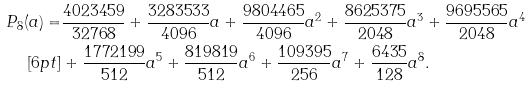<formula> <loc_0><loc_0><loc_500><loc_500>P _ { 8 } ( a ) = & \frac { 4 0 2 3 4 5 9 } { 3 2 7 6 8 } + \frac { 3 2 8 3 5 3 3 } { 4 0 9 6 } a + \frac { 9 8 0 4 4 6 5 } { 4 0 9 6 } a ^ { 2 } + \frac { 8 6 2 5 3 7 5 } { 2 0 4 8 } a ^ { 3 } + \frac { 9 6 9 5 5 6 5 } { 2 0 4 8 } a ^ { 4 } \\ [ 6 p t ] & + \frac { 1 7 7 2 1 9 9 } { 5 1 2 } a ^ { 5 } + \frac { 8 1 9 8 1 9 } { 5 1 2 } a ^ { 6 } + \frac { 1 0 9 3 9 5 } { 2 5 6 } a ^ { 7 } + \frac { 6 4 3 5 } { 1 2 8 } a ^ { 8 } .</formula> 